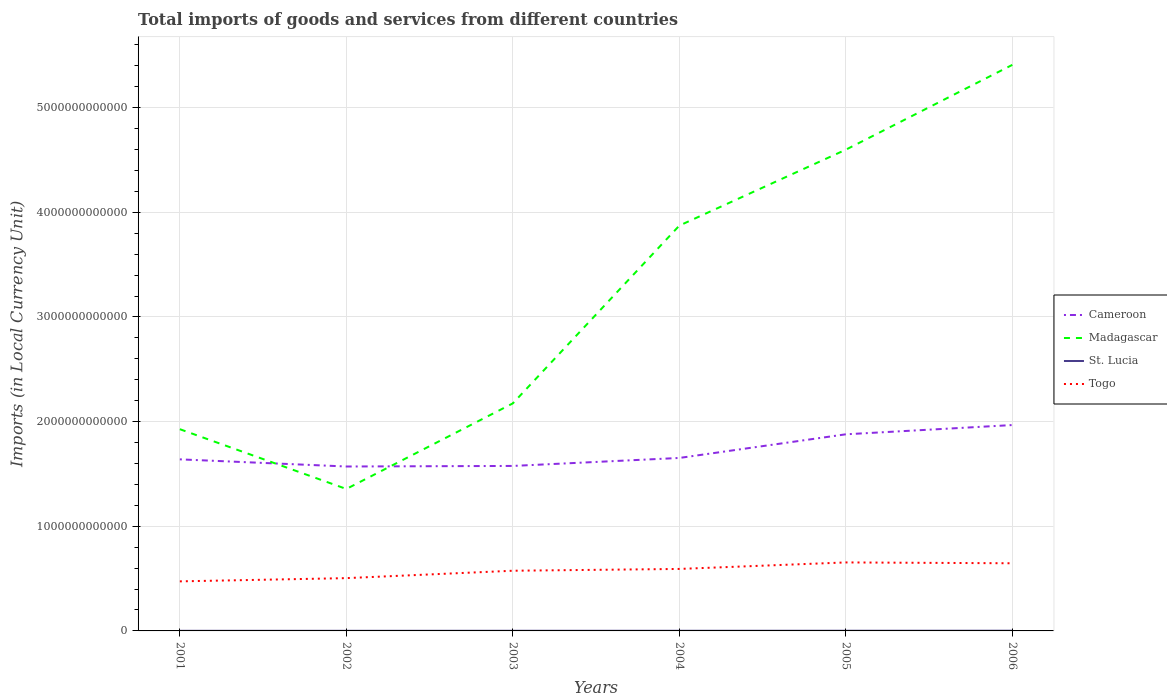Is the number of lines equal to the number of legend labels?
Provide a short and direct response. Yes. Across all years, what is the maximum Amount of goods and services imports in Madagascar?
Ensure brevity in your answer.  1.36e+12. In which year was the Amount of goods and services imports in Cameroon maximum?
Offer a very short reply. 2002. What is the total Amount of goods and services imports in St. Lucia in the graph?
Offer a terse response. -2.63e+08. What is the difference between the highest and the second highest Amount of goods and services imports in Cameroon?
Give a very brief answer. 3.96e+11. What is the difference between two consecutive major ticks on the Y-axis?
Offer a terse response. 1.00e+12. Are the values on the major ticks of Y-axis written in scientific E-notation?
Keep it short and to the point. No. Does the graph contain any zero values?
Offer a very short reply. No. Does the graph contain grids?
Ensure brevity in your answer.  Yes. How many legend labels are there?
Your answer should be very brief. 4. How are the legend labels stacked?
Offer a terse response. Vertical. What is the title of the graph?
Give a very brief answer. Total imports of goods and services from different countries. Does "Channel Islands" appear as one of the legend labels in the graph?
Offer a terse response. No. What is the label or title of the Y-axis?
Keep it short and to the point. Imports (in Local Currency Unit). What is the Imports (in Local Currency Unit) of Cameroon in 2001?
Make the answer very short. 1.64e+12. What is the Imports (in Local Currency Unit) of Madagascar in 2001?
Offer a very short reply. 1.93e+12. What is the Imports (in Local Currency Unit) in St. Lucia in 2001?
Offer a terse response. 1.09e+09. What is the Imports (in Local Currency Unit) in Togo in 2001?
Give a very brief answer. 4.74e+11. What is the Imports (in Local Currency Unit) in Cameroon in 2002?
Your answer should be compact. 1.57e+12. What is the Imports (in Local Currency Unit) of Madagascar in 2002?
Keep it short and to the point. 1.36e+12. What is the Imports (in Local Currency Unit) of St. Lucia in 2002?
Provide a succinct answer. 1.08e+09. What is the Imports (in Local Currency Unit) in Togo in 2002?
Your answer should be compact. 5.04e+11. What is the Imports (in Local Currency Unit) in Cameroon in 2003?
Your response must be concise. 1.58e+12. What is the Imports (in Local Currency Unit) of Madagascar in 2003?
Your response must be concise. 2.17e+12. What is the Imports (in Local Currency Unit) in St. Lucia in 2003?
Your answer should be very brief. 1.35e+09. What is the Imports (in Local Currency Unit) in Togo in 2003?
Offer a very short reply. 5.75e+11. What is the Imports (in Local Currency Unit) in Cameroon in 2004?
Provide a short and direct response. 1.65e+12. What is the Imports (in Local Currency Unit) in Madagascar in 2004?
Your answer should be very brief. 3.87e+12. What is the Imports (in Local Currency Unit) of St. Lucia in 2004?
Keep it short and to the point. 1.35e+09. What is the Imports (in Local Currency Unit) of Togo in 2004?
Provide a succinct answer. 5.92e+11. What is the Imports (in Local Currency Unit) of Cameroon in 2005?
Offer a terse response. 1.88e+12. What is the Imports (in Local Currency Unit) in Madagascar in 2005?
Make the answer very short. 4.60e+12. What is the Imports (in Local Currency Unit) in St. Lucia in 2005?
Ensure brevity in your answer.  1.61e+09. What is the Imports (in Local Currency Unit) in Togo in 2005?
Offer a very short reply. 6.54e+11. What is the Imports (in Local Currency Unit) of Cameroon in 2006?
Offer a very short reply. 1.97e+12. What is the Imports (in Local Currency Unit) in Madagascar in 2006?
Your response must be concise. 5.41e+12. What is the Imports (in Local Currency Unit) in St. Lucia in 2006?
Your answer should be compact. 1.91e+09. What is the Imports (in Local Currency Unit) in Togo in 2006?
Your answer should be very brief. 6.46e+11. Across all years, what is the maximum Imports (in Local Currency Unit) in Cameroon?
Give a very brief answer. 1.97e+12. Across all years, what is the maximum Imports (in Local Currency Unit) of Madagascar?
Your response must be concise. 5.41e+12. Across all years, what is the maximum Imports (in Local Currency Unit) in St. Lucia?
Give a very brief answer. 1.91e+09. Across all years, what is the maximum Imports (in Local Currency Unit) in Togo?
Offer a very short reply. 6.54e+11. Across all years, what is the minimum Imports (in Local Currency Unit) in Cameroon?
Your answer should be compact. 1.57e+12. Across all years, what is the minimum Imports (in Local Currency Unit) of Madagascar?
Your response must be concise. 1.36e+12. Across all years, what is the minimum Imports (in Local Currency Unit) of St. Lucia?
Ensure brevity in your answer.  1.08e+09. Across all years, what is the minimum Imports (in Local Currency Unit) in Togo?
Your answer should be very brief. 4.74e+11. What is the total Imports (in Local Currency Unit) of Cameroon in the graph?
Make the answer very short. 1.03e+13. What is the total Imports (in Local Currency Unit) in Madagascar in the graph?
Your answer should be compact. 1.93e+13. What is the total Imports (in Local Currency Unit) of St. Lucia in the graph?
Your answer should be very brief. 8.38e+09. What is the total Imports (in Local Currency Unit) of Togo in the graph?
Your response must be concise. 3.45e+12. What is the difference between the Imports (in Local Currency Unit) in Cameroon in 2001 and that in 2002?
Your answer should be compact. 6.83e+1. What is the difference between the Imports (in Local Currency Unit) in Madagascar in 2001 and that in 2002?
Provide a short and direct response. 5.71e+11. What is the difference between the Imports (in Local Currency Unit) in St. Lucia in 2001 and that in 2002?
Your answer should be very brief. 4.70e+06. What is the difference between the Imports (in Local Currency Unit) in Togo in 2001 and that in 2002?
Offer a terse response. -3.09e+1. What is the difference between the Imports (in Local Currency Unit) in Cameroon in 2001 and that in 2003?
Ensure brevity in your answer.  6.29e+1. What is the difference between the Imports (in Local Currency Unit) of Madagascar in 2001 and that in 2003?
Make the answer very short. -2.47e+11. What is the difference between the Imports (in Local Currency Unit) of St. Lucia in 2001 and that in 2003?
Offer a very short reply. -2.62e+08. What is the difference between the Imports (in Local Currency Unit) of Togo in 2001 and that in 2003?
Your response must be concise. -1.02e+11. What is the difference between the Imports (in Local Currency Unit) of Cameroon in 2001 and that in 2004?
Provide a short and direct response. -1.34e+1. What is the difference between the Imports (in Local Currency Unit) in Madagascar in 2001 and that in 2004?
Make the answer very short. -1.95e+12. What is the difference between the Imports (in Local Currency Unit) of St. Lucia in 2001 and that in 2004?
Make the answer very short. -2.63e+08. What is the difference between the Imports (in Local Currency Unit) in Togo in 2001 and that in 2004?
Offer a terse response. -1.19e+11. What is the difference between the Imports (in Local Currency Unit) of Cameroon in 2001 and that in 2005?
Provide a short and direct response. -2.39e+11. What is the difference between the Imports (in Local Currency Unit) in Madagascar in 2001 and that in 2005?
Provide a succinct answer. -2.67e+12. What is the difference between the Imports (in Local Currency Unit) of St. Lucia in 2001 and that in 2005?
Offer a terse response. -5.19e+08. What is the difference between the Imports (in Local Currency Unit) in Togo in 2001 and that in 2005?
Keep it short and to the point. -1.81e+11. What is the difference between the Imports (in Local Currency Unit) of Cameroon in 2001 and that in 2006?
Offer a terse response. -3.28e+11. What is the difference between the Imports (in Local Currency Unit) in Madagascar in 2001 and that in 2006?
Give a very brief answer. -3.48e+12. What is the difference between the Imports (in Local Currency Unit) in St. Lucia in 2001 and that in 2006?
Provide a short and direct response. -8.21e+08. What is the difference between the Imports (in Local Currency Unit) in Togo in 2001 and that in 2006?
Make the answer very short. -1.73e+11. What is the difference between the Imports (in Local Currency Unit) in Cameroon in 2002 and that in 2003?
Your response must be concise. -5.41e+09. What is the difference between the Imports (in Local Currency Unit) of Madagascar in 2002 and that in 2003?
Your answer should be very brief. -8.18e+11. What is the difference between the Imports (in Local Currency Unit) in St. Lucia in 2002 and that in 2003?
Keep it short and to the point. -2.67e+08. What is the difference between the Imports (in Local Currency Unit) in Togo in 2002 and that in 2003?
Make the answer very short. -7.07e+1. What is the difference between the Imports (in Local Currency Unit) in Cameroon in 2002 and that in 2004?
Provide a short and direct response. -8.17e+1. What is the difference between the Imports (in Local Currency Unit) of Madagascar in 2002 and that in 2004?
Your answer should be compact. -2.52e+12. What is the difference between the Imports (in Local Currency Unit) in St. Lucia in 2002 and that in 2004?
Offer a terse response. -2.68e+08. What is the difference between the Imports (in Local Currency Unit) of Togo in 2002 and that in 2004?
Give a very brief answer. -8.78e+1. What is the difference between the Imports (in Local Currency Unit) of Cameroon in 2002 and that in 2005?
Give a very brief answer. -3.08e+11. What is the difference between the Imports (in Local Currency Unit) in Madagascar in 2002 and that in 2005?
Make the answer very short. -3.24e+12. What is the difference between the Imports (in Local Currency Unit) in St. Lucia in 2002 and that in 2005?
Your response must be concise. -5.23e+08. What is the difference between the Imports (in Local Currency Unit) in Togo in 2002 and that in 2005?
Offer a terse response. -1.50e+11. What is the difference between the Imports (in Local Currency Unit) of Cameroon in 2002 and that in 2006?
Ensure brevity in your answer.  -3.96e+11. What is the difference between the Imports (in Local Currency Unit) in Madagascar in 2002 and that in 2006?
Provide a succinct answer. -4.05e+12. What is the difference between the Imports (in Local Currency Unit) of St. Lucia in 2002 and that in 2006?
Provide a short and direct response. -8.25e+08. What is the difference between the Imports (in Local Currency Unit) in Togo in 2002 and that in 2006?
Your answer should be very brief. -1.42e+11. What is the difference between the Imports (in Local Currency Unit) of Cameroon in 2003 and that in 2004?
Keep it short and to the point. -7.63e+1. What is the difference between the Imports (in Local Currency Unit) of Madagascar in 2003 and that in 2004?
Your answer should be very brief. -1.70e+12. What is the difference between the Imports (in Local Currency Unit) of St. Lucia in 2003 and that in 2004?
Provide a short and direct response. -1.60e+06. What is the difference between the Imports (in Local Currency Unit) in Togo in 2003 and that in 2004?
Keep it short and to the point. -1.71e+1. What is the difference between the Imports (in Local Currency Unit) of Cameroon in 2003 and that in 2005?
Ensure brevity in your answer.  -3.02e+11. What is the difference between the Imports (in Local Currency Unit) of Madagascar in 2003 and that in 2005?
Give a very brief answer. -2.42e+12. What is the difference between the Imports (in Local Currency Unit) of St. Lucia in 2003 and that in 2005?
Your answer should be very brief. -2.57e+08. What is the difference between the Imports (in Local Currency Unit) in Togo in 2003 and that in 2005?
Your answer should be very brief. -7.93e+1. What is the difference between the Imports (in Local Currency Unit) of Cameroon in 2003 and that in 2006?
Offer a terse response. -3.91e+11. What is the difference between the Imports (in Local Currency Unit) in Madagascar in 2003 and that in 2006?
Your answer should be compact. -3.23e+12. What is the difference between the Imports (in Local Currency Unit) in St. Lucia in 2003 and that in 2006?
Provide a succinct answer. -5.59e+08. What is the difference between the Imports (in Local Currency Unit) of Togo in 2003 and that in 2006?
Your answer should be very brief. -7.13e+1. What is the difference between the Imports (in Local Currency Unit) in Cameroon in 2004 and that in 2005?
Provide a succinct answer. -2.26e+11. What is the difference between the Imports (in Local Currency Unit) in Madagascar in 2004 and that in 2005?
Offer a terse response. -7.25e+11. What is the difference between the Imports (in Local Currency Unit) in St. Lucia in 2004 and that in 2005?
Your answer should be compact. -2.55e+08. What is the difference between the Imports (in Local Currency Unit) in Togo in 2004 and that in 2005?
Make the answer very short. -6.22e+1. What is the difference between the Imports (in Local Currency Unit) in Cameroon in 2004 and that in 2006?
Make the answer very short. -3.14e+11. What is the difference between the Imports (in Local Currency Unit) of Madagascar in 2004 and that in 2006?
Your answer should be very brief. -1.54e+12. What is the difference between the Imports (in Local Currency Unit) in St. Lucia in 2004 and that in 2006?
Ensure brevity in your answer.  -5.57e+08. What is the difference between the Imports (in Local Currency Unit) in Togo in 2004 and that in 2006?
Ensure brevity in your answer.  -5.42e+1. What is the difference between the Imports (in Local Currency Unit) in Cameroon in 2005 and that in 2006?
Your response must be concise. -8.83e+1. What is the difference between the Imports (in Local Currency Unit) in Madagascar in 2005 and that in 2006?
Ensure brevity in your answer.  -8.10e+11. What is the difference between the Imports (in Local Currency Unit) of St. Lucia in 2005 and that in 2006?
Provide a short and direct response. -3.02e+08. What is the difference between the Imports (in Local Currency Unit) of Togo in 2005 and that in 2006?
Offer a very short reply. 8.03e+09. What is the difference between the Imports (in Local Currency Unit) of Cameroon in 2001 and the Imports (in Local Currency Unit) of Madagascar in 2002?
Ensure brevity in your answer.  2.83e+11. What is the difference between the Imports (in Local Currency Unit) in Cameroon in 2001 and the Imports (in Local Currency Unit) in St. Lucia in 2002?
Keep it short and to the point. 1.64e+12. What is the difference between the Imports (in Local Currency Unit) of Cameroon in 2001 and the Imports (in Local Currency Unit) of Togo in 2002?
Offer a very short reply. 1.13e+12. What is the difference between the Imports (in Local Currency Unit) of Madagascar in 2001 and the Imports (in Local Currency Unit) of St. Lucia in 2002?
Offer a terse response. 1.93e+12. What is the difference between the Imports (in Local Currency Unit) of Madagascar in 2001 and the Imports (in Local Currency Unit) of Togo in 2002?
Offer a very short reply. 1.42e+12. What is the difference between the Imports (in Local Currency Unit) of St. Lucia in 2001 and the Imports (in Local Currency Unit) of Togo in 2002?
Offer a very short reply. -5.03e+11. What is the difference between the Imports (in Local Currency Unit) of Cameroon in 2001 and the Imports (in Local Currency Unit) of Madagascar in 2003?
Ensure brevity in your answer.  -5.35e+11. What is the difference between the Imports (in Local Currency Unit) in Cameroon in 2001 and the Imports (in Local Currency Unit) in St. Lucia in 2003?
Offer a terse response. 1.64e+12. What is the difference between the Imports (in Local Currency Unit) of Cameroon in 2001 and the Imports (in Local Currency Unit) of Togo in 2003?
Give a very brief answer. 1.06e+12. What is the difference between the Imports (in Local Currency Unit) in Madagascar in 2001 and the Imports (in Local Currency Unit) in St. Lucia in 2003?
Your answer should be compact. 1.93e+12. What is the difference between the Imports (in Local Currency Unit) in Madagascar in 2001 and the Imports (in Local Currency Unit) in Togo in 2003?
Offer a terse response. 1.35e+12. What is the difference between the Imports (in Local Currency Unit) in St. Lucia in 2001 and the Imports (in Local Currency Unit) in Togo in 2003?
Offer a terse response. -5.74e+11. What is the difference between the Imports (in Local Currency Unit) of Cameroon in 2001 and the Imports (in Local Currency Unit) of Madagascar in 2004?
Provide a short and direct response. -2.23e+12. What is the difference between the Imports (in Local Currency Unit) in Cameroon in 2001 and the Imports (in Local Currency Unit) in St. Lucia in 2004?
Offer a terse response. 1.64e+12. What is the difference between the Imports (in Local Currency Unit) of Cameroon in 2001 and the Imports (in Local Currency Unit) of Togo in 2004?
Your response must be concise. 1.05e+12. What is the difference between the Imports (in Local Currency Unit) in Madagascar in 2001 and the Imports (in Local Currency Unit) in St. Lucia in 2004?
Offer a terse response. 1.93e+12. What is the difference between the Imports (in Local Currency Unit) in Madagascar in 2001 and the Imports (in Local Currency Unit) in Togo in 2004?
Provide a short and direct response. 1.34e+12. What is the difference between the Imports (in Local Currency Unit) of St. Lucia in 2001 and the Imports (in Local Currency Unit) of Togo in 2004?
Your answer should be very brief. -5.91e+11. What is the difference between the Imports (in Local Currency Unit) in Cameroon in 2001 and the Imports (in Local Currency Unit) in Madagascar in 2005?
Your response must be concise. -2.96e+12. What is the difference between the Imports (in Local Currency Unit) of Cameroon in 2001 and the Imports (in Local Currency Unit) of St. Lucia in 2005?
Offer a terse response. 1.64e+12. What is the difference between the Imports (in Local Currency Unit) of Cameroon in 2001 and the Imports (in Local Currency Unit) of Togo in 2005?
Your answer should be compact. 9.85e+11. What is the difference between the Imports (in Local Currency Unit) in Madagascar in 2001 and the Imports (in Local Currency Unit) in St. Lucia in 2005?
Provide a succinct answer. 1.93e+12. What is the difference between the Imports (in Local Currency Unit) in Madagascar in 2001 and the Imports (in Local Currency Unit) in Togo in 2005?
Ensure brevity in your answer.  1.27e+12. What is the difference between the Imports (in Local Currency Unit) in St. Lucia in 2001 and the Imports (in Local Currency Unit) in Togo in 2005?
Your response must be concise. -6.53e+11. What is the difference between the Imports (in Local Currency Unit) in Cameroon in 2001 and the Imports (in Local Currency Unit) in Madagascar in 2006?
Your answer should be compact. -3.77e+12. What is the difference between the Imports (in Local Currency Unit) of Cameroon in 2001 and the Imports (in Local Currency Unit) of St. Lucia in 2006?
Ensure brevity in your answer.  1.64e+12. What is the difference between the Imports (in Local Currency Unit) in Cameroon in 2001 and the Imports (in Local Currency Unit) in Togo in 2006?
Offer a terse response. 9.93e+11. What is the difference between the Imports (in Local Currency Unit) in Madagascar in 2001 and the Imports (in Local Currency Unit) in St. Lucia in 2006?
Your answer should be compact. 1.93e+12. What is the difference between the Imports (in Local Currency Unit) in Madagascar in 2001 and the Imports (in Local Currency Unit) in Togo in 2006?
Offer a very short reply. 1.28e+12. What is the difference between the Imports (in Local Currency Unit) of St. Lucia in 2001 and the Imports (in Local Currency Unit) of Togo in 2006?
Keep it short and to the point. -6.45e+11. What is the difference between the Imports (in Local Currency Unit) of Cameroon in 2002 and the Imports (in Local Currency Unit) of Madagascar in 2003?
Ensure brevity in your answer.  -6.03e+11. What is the difference between the Imports (in Local Currency Unit) of Cameroon in 2002 and the Imports (in Local Currency Unit) of St. Lucia in 2003?
Give a very brief answer. 1.57e+12. What is the difference between the Imports (in Local Currency Unit) of Cameroon in 2002 and the Imports (in Local Currency Unit) of Togo in 2003?
Offer a very short reply. 9.96e+11. What is the difference between the Imports (in Local Currency Unit) in Madagascar in 2002 and the Imports (in Local Currency Unit) in St. Lucia in 2003?
Ensure brevity in your answer.  1.35e+12. What is the difference between the Imports (in Local Currency Unit) in Madagascar in 2002 and the Imports (in Local Currency Unit) in Togo in 2003?
Keep it short and to the point. 7.81e+11. What is the difference between the Imports (in Local Currency Unit) of St. Lucia in 2002 and the Imports (in Local Currency Unit) of Togo in 2003?
Offer a terse response. -5.74e+11. What is the difference between the Imports (in Local Currency Unit) of Cameroon in 2002 and the Imports (in Local Currency Unit) of Madagascar in 2004?
Make the answer very short. -2.30e+12. What is the difference between the Imports (in Local Currency Unit) of Cameroon in 2002 and the Imports (in Local Currency Unit) of St. Lucia in 2004?
Offer a very short reply. 1.57e+12. What is the difference between the Imports (in Local Currency Unit) in Cameroon in 2002 and the Imports (in Local Currency Unit) in Togo in 2004?
Provide a short and direct response. 9.79e+11. What is the difference between the Imports (in Local Currency Unit) of Madagascar in 2002 and the Imports (in Local Currency Unit) of St. Lucia in 2004?
Offer a very short reply. 1.35e+12. What is the difference between the Imports (in Local Currency Unit) of Madagascar in 2002 and the Imports (in Local Currency Unit) of Togo in 2004?
Provide a succinct answer. 7.64e+11. What is the difference between the Imports (in Local Currency Unit) in St. Lucia in 2002 and the Imports (in Local Currency Unit) in Togo in 2004?
Make the answer very short. -5.91e+11. What is the difference between the Imports (in Local Currency Unit) of Cameroon in 2002 and the Imports (in Local Currency Unit) of Madagascar in 2005?
Ensure brevity in your answer.  -3.03e+12. What is the difference between the Imports (in Local Currency Unit) of Cameroon in 2002 and the Imports (in Local Currency Unit) of St. Lucia in 2005?
Give a very brief answer. 1.57e+12. What is the difference between the Imports (in Local Currency Unit) in Cameroon in 2002 and the Imports (in Local Currency Unit) in Togo in 2005?
Make the answer very short. 9.17e+11. What is the difference between the Imports (in Local Currency Unit) of Madagascar in 2002 and the Imports (in Local Currency Unit) of St. Lucia in 2005?
Offer a very short reply. 1.35e+12. What is the difference between the Imports (in Local Currency Unit) in Madagascar in 2002 and the Imports (in Local Currency Unit) in Togo in 2005?
Ensure brevity in your answer.  7.02e+11. What is the difference between the Imports (in Local Currency Unit) in St. Lucia in 2002 and the Imports (in Local Currency Unit) in Togo in 2005?
Provide a short and direct response. -6.53e+11. What is the difference between the Imports (in Local Currency Unit) in Cameroon in 2002 and the Imports (in Local Currency Unit) in Madagascar in 2006?
Your response must be concise. -3.84e+12. What is the difference between the Imports (in Local Currency Unit) in Cameroon in 2002 and the Imports (in Local Currency Unit) in St. Lucia in 2006?
Offer a very short reply. 1.57e+12. What is the difference between the Imports (in Local Currency Unit) in Cameroon in 2002 and the Imports (in Local Currency Unit) in Togo in 2006?
Make the answer very short. 9.25e+11. What is the difference between the Imports (in Local Currency Unit) in Madagascar in 2002 and the Imports (in Local Currency Unit) in St. Lucia in 2006?
Your response must be concise. 1.35e+12. What is the difference between the Imports (in Local Currency Unit) in Madagascar in 2002 and the Imports (in Local Currency Unit) in Togo in 2006?
Offer a very short reply. 7.10e+11. What is the difference between the Imports (in Local Currency Unit) of St. Lucia in 2002 and the Imports (in Local Currency Unit) of Togo in 2006?
Make the answer very short. -6.45e+11. What is the difference between the Imports (in Local Currency Unit) of Cameroon in 2003 and the Imports (in Local Currency Unit) of Madagascar in 2004?
Your answer should be very brief. -2.30e+12. What is the difference between the Imports (in Local Currency Unit) in Cameroon in 2003 and the Imports (in Local Currency Unit) in St. Lucia in 2004?
Your answer should be very brief. 1.58e+12. What is the difference between the Imports (in Local Currency Unit) in Cameroon in 2003 and the Imports (in Local Currency Unit) in Togo in 2004?
Provide a succinct answer. 9.84e+11. What is the difference between the Imports (in Local Currency Unit) in Madagascar in 2003 and the Imports (in Local Currency Unit) in St. Lucia in 2004?
Keep it short and to the point. 2.17e+12. What is the difference between the Imports (in Local Currency Unit) of Madagascar in 2003 and the Imports (in Local Currency Unit) of Togo in 2004?
Give a very brief answer. 1.58e+12. What is the difference between the Imports (in Local Currency Unit) of St. Lucia in 2003 and the Imports (in Local Currency Unit) of Togo in 2004?
Ensure brevity in your answer.  -5.91e+11. What is the difference between the Imports (in Local Currency Unit) of Cameroon in 2003 and the Imports (in Local Currency Unit) of Madagascar in 2005?
Your response must be concise. -3.02e+12. What is the difference between the Imports (in Local Currency Unit) of Cameroon in 2003 and the Imports (in Local Currency Unit) of St. Lucia in 2005?
Offer a terse response. 1.57e+12. What is the difference between the Imports (in Local Currency Unit) of Cameroon in 2003 and the Imports (in Local Currency Unit) of Togo in 2005?
Your answer should be very brief. 9.22e+11. What is the difference between the Imports (in Local Currency Unit) in Madagascar in 2003 and the Imports (in Local Currency Unit) in St. Lucia in 2005?
Ensure brevity in your answer.  2.17e+12. What is the difference between the Imports (in Local Currency Unit) in Madagascar in 2003 and the Imports (in Local Currency Unit) in Togo in 2005?
Offer a terse response. 1.52e+12. What is the difference between the Imports (in Local Currency Unit) in St. Lucia in 2003 and the Imports (in Local Currency Unit) in Togo in 2005?
Make the answer very short. -6.53e+11. What is the difference between the Imports (in Local Currency Unit) in Cameroon in 2003 and the Imports (in Local Currency Unit) in Madagascar in 2006?
Provide a succinct answer. -3.83e+12. What is the difference between the Imports (in Local Currency Unit) in Cameroon in 2003 and the Imports (in Local Currency Unit) in St. Lucia in 2006?
Give a very brief answer. 1.57e+12. What is the difference between the Imports (in Local Currency Unit) in Cameroon in 2003 and the Imports (in Local Currency Unit) in Togo in 2006?
Offer a terse response. 9.30e+11. What is the difference between the Imports (in Local Currency Unit) in Madagascar in 2003 and the Imports (in Local Currency Unit) in St. Lucia in 2006?
Ensure brevity in your answer.  2.17e+12. What is the difference between the Imports (in Local Currency Unit) of Madagascar in 2003 and the Imports (in Local Currency Unit) of Togo in 2006?
Ensure brevity in your answer.  1.53e+12. What is the difference between the Imports (in Local Currency Unit) in St. Lucia in 2003 and the Imports (in Local Currency Unit) in Togo in 2006?
Offer a terse response. -6.45e+11. What is the difference between the Imports (in Local Currency Unit) of Cameroon in 2004 and the Imports (in Local Currency Unit) of Madagascar in 2005?
Your answer should be very brief. -2.95e+12. What is the difference between the Imports (in Local Currency Unit) of Cameroon in 2004 and the Imports (in Local Currency Unit) of St. Lucia in 2005?
Your answer should be compact. 1.65e+12. What is the difference between the Imports (in Local Currency Unit) of Cameroon in 2004 and the Imports (in Local Currency Unit) of Togo in 2005?
Offer a very short reply. 9.98e+11. What is the difference between the Imports (in Local Currency Unit) in Madagascar in 2004 and the Imports (in Local Currency Unit) in St. Lucia in 2005?
Make the answer very short. 3.87e+12. What is the difference between the Imports (in Local Currency Unit) of Madagascar in 2004 and the Imports (in Local Currency Unit) of Togo in 2005?
Your answer should be compact. 3.22e+12. What is the difference between the Imports (in Local Currency Unit) of St. Lucia in 2004 and the Imports (in Local Currency Unit) of Togo in 2005?
Ensure brevity in your answer.  -6.53e+11. What is the difference between the Imports (in Local Currency Unit) of Cameroon in 2004 and the Imports (in Local Currency Unit) of Madagascar in 2006?
Your response must be concise. -3.76e+12. What is the difference between the Imports (in Local Currency Unit) of Cameroon in 2004 and the Imports (in Local Currency Unit) of St. Lucia in 2006?
Offer a very short reply. 1.65e+12. What is the difference between the Imports (in Local Currency Unit) of Cameroon in 2004 and the Imports (in Local Currency Unit) of Togo in 2006?
Give a very brief answer. 1.01e+12. What is the difference between the Imports (in Local Currency Unit) of Madagascar in 2004 and the Imports (in Local Currency Unit) of St. Lucia in 2006?
Make the answer very short. 3.87e+12. What is the difference between the Imports (in Local Currency Unit) in Madagascar in 2004 and the Imports (in Local Currency Unit) in Togo in 2006?
Your answer should be very brief. 3.23e+12. What is the difference between the Imports (in Local Currency Unit) of St. Lucia in 2004 and the Imports (in Local Currency Unit) of Togo in 2006?
Your answer should be compact. -6.45e+11. What is the difference between the Imports (in Local Currency Unit) of Cameroon in 2005 and the Imports (in Local Currency Unit) of Madagascar in 2006?
Provide a succinct answer. -3.53e+12. What is the difference between the Imports (in Local Currency Unit) of Cameroon in 2005 and the Imports (in Local Currency Unit) of St. Lucia in 2006?
Offer a terse response. 1.88e+12. What is the difference between the Imports (in Local Currency Unit) of Cameroon in 2005 and the Imports (in Local Currency Unit) of Togo in 2006?
Ensure brevity in your answer.  1.23e+12. What is the difference between the Imports (in Local Currency Unit) in Madagascar in 2005 and the Imports (in Local Currency Unit) in St. Lucia in 2006?
Give a very brief answer. 4.60e+12. What is the difference between the Imports (in Local Currency Unit) of Madagascar in 2005 and the Imports (in Local Currency Unit) of Togo in 2006?
Offer a very short reply. 3.95e+12. What is the difference between the Imports (in Local Currency Unit) of St. Lucia in 2005 and the Imports (in Local Currency Unit) of Togo in 2006?
Offer a terse response. -6.45e+11. What is the average Imports (in Local Currency Unit) in Cameroon per year?
Your answer should be compact. 1.71e+12. What is the average Imports (in Local Currency Unit) in Madagascar per year?
Offer a terse response. 3.22e+12. What is the average Imports (in Local Currency Unit) in St. Lucia per year?
Keep it short and to the point. 1.40e+09. What is the average Imports (in Local Currency Unit) of Togo per year?
Offer a terse response. 5.74e+11. In the year 2001, what is the difference between the Imports (in Local Currency Unit) of Cameroon and Imports (in Local Currency Unit) of Madagascar?
Offer a very short reply. -2.88e+11. In the year 2001, what is the difference between the Imports (in Local Currency Unit) in Cameroon and Imports (in Local Currency Unit) in St. Lucia?
Provide a short and direct response. 1.64e+12. In the year 2001, what is the difference between the Imports (in Local Currency Unit) in Cameroon and Imports (in Local Currency Unit) in Togo?
Offer a very short reply. 1.17e+12. In the year 2001, what is the difference between the Imports (in Local Currency Unit) of Madagascar and Imports (in Local Currency Unit) of St. Lucia?
Provide a short and direct response. 1.93e+12. In the year 2001, what is the difference between the Imports (in Local Currency Unit) in Madagascar and Imports (in Local Currency Unit) in Togo?
Make the answer very short. 1.45e+12. In the year 2001, what is the difference between the Imports (in Local Currency Unit) in St. Lucia and Imports (in Local Currency Unit) in Togo?
Give a very brief answer. -4.72e+11. In the year 2002, what is the difference between the Imports (in Local Currency Unit) in Cameroon and Imports (in Local Currency Unit) in Madagascar?
Ensure brevity in your answer.  2.15e+11. In the year 2002, what is the difference between the Imports (in Local Currency Unit) in Cameroon and Imports (in Local Currency Unit) in St. Lucia?
Ensure brevity in your answer.  1.57e+12. In the year 2002, what is the difference between the Imports (in Local Currency Unit) in Cameroon and Imports (in Local Currency Unit) in Togo?
Your answer should be compact. 1.07e+12. In the year 2002, what is the difference between the Imports (in Local Currency Unit) of Madagascar and Imports (in Local Currency Unit) of St. Lucia?
Ensure brevity in your answer.  1.36e+12. In the year 2002, what is the difference between the Imports (in Local Currency Unit) of Madagascar and Imports (in Local Currency Unit) of Togo?
Give a very brief answer. 8.52e+11. In the year 2002, what is the difference between the Imports (in Local Currency Unit) of St. Lucia and Imports (in Local Currency Unit) of Togo?
Ensure brevity in your answer.  -5.03e+11. In the year 2003, what is the difference between the Imports (in Local Currency Unit) of Cameroon and Imports (in Local Currency Unit) of Madagascar?
Provide a succinct answer. -5.98e+11. In the year 2003, what is the difference between the Imports (in Local Currency Unit) in Cameroon and Imports (in Local Currency Unit) in St. Lucia?
Your response must be concise. 1.58e+12. In the year 2003, what is the difference between the Imports (in Local Currency Unit) of Cameroon and Imports (in Local Currency Unit) of Togo?
Give a very brief answer. 1.00e+12. In the year 2003, what is the difference between the Imports (in Local Currency Unit) in Madagascar and Imports (in Local Currency Unit) in St. Lucia?
Provide a succinct answer. 2.17e+12. In the year 2003, what is the difference between the Imports (in Local Currency Unit) of Madagascar and Imports (in Local Currency Unit) of Togo?
Provide a succinct answer. 1.60e+12. In the year 2003, what is the difference between the Imports (in Local Currency Unit) of St. Lucia and Imports (in Local Currency Unit) of Togo?
Your response must be concise. -5.74e+11. In the year 2004, what is the difference between the Imports (in Local Currency Unit) in Cameroon and Imports (in Local Currency Unit) in Madagascar?
Your response must be concise. -2.22e+12. In the year 2004, what is the difference between the Imports (in Local Currency Unit) of Cameroon and Imports (in Local Currency Unit) of St. Lucia?
Your answer should be compact. 1.65e+12. In the year 2004, what is the difference between the Imports (in Local Currency Unit) of Cameroon and Imports (in Local Currency Unit) of Togo?
Give a very brief answer. 1.06e+12. In the year 2004, what is the difference between the Imports (in Local Currency Unit) of Madagascar and Imports (in Local Currency Unit) of St. Lucia?
Provide a succinct answer. 3.87e+12. In the year 2004, what is the difference between the Imports (in Local Currency Unit) of Madagascar and Imports (in Local Currency Unit) of Togo?
Your answer should be compact. 3.28e+12. In the year 2004, what is the difference between the Imports (in Local Currency Unit) of St. Lucia and Imports (in Local Currency Unit) of Togo?
Ensure brevity in your answer.  -5.91e+11. In the year 2005, what is the difference between the Imports (in Local Currency Unit) in Cameroon and Imports (in Local Currency Unit) in Madagascar?
Ensure brevity in your answer.  -2.72e+12. In the year 2005, what is the difference between the Imports (in Local Currency Unit) in Cameroon and Imports (in Local Currency Unit) in St. Lucia?
Ensure brevity in your answer.  1.88e+12. In the year 2005, what is the difference between the Imports (in Local Currency Unit) of Cameroon and Imports (in Local Currency Unit) of Togo?
Offer a terse response. 1.22e+12. In the year 2005, what is the difference between the Imports (in Local Currency Unit) in Madagascar and Imports (in Local Currency Unit) in St. Lucia?
Your response must be concise. 4.60e+12. In the year 2005, what is the difference between the Imports (in Local Currency Unit) of Madagascar and Imports (in Local Currency Unit) of Togo?
Ensure brevity in your answer.  3.94e+12. In the year 2005, what is the difference between the Imports (in Local Currency Unit) in St. Lucia and Imports (in Local Currency Unit) in Togo?
Your answer should be very brief. -6.53e+11. In the year 2006, what is the difference between the Imports (in Local Currency Unit) in Cameroon and Imports (in Local Currency Unit) in Madagascar?
Provide a short and direct response. -3.44e+12. In the year 2006, what is the difference between the Imports (in Local Currency Unit) in Cameroon and Imports (in Local Currency Unit) in St. Lucia?
Provide a short and direct response. 1.97e+12. In the year 2006, what is the difference between the Imports (in Local Currency Unit) of Cameroon and Imports (in Local Currency Unit) of Togo?
Offer a terse response. 1.32e+12. In the year 2006, what is the difference between the Imports (in Local Currency Unit) in Madagascar and Imports (in Local Currency Unit) in St. Lucia?
Offer a very short reply. 5.41e+12. In the year 2006, what is the difference between the Imports (in Local Currency Unit) of Madagascar and Imports (in Local Currency Unit) of Togo?
Keep it short and to the point. 4.76e+12. In the year 2006, what is the difference between the Imports (in Local Currency Unit) in St. Lucia and Imports (in Local Currency Unit) in Togo?
Your answer should be compact. -6.44e+11. What is the ratio of the Imports (in Local Currency Unit) of Cameroon in 2001 to that in 2002?
Offer a terse response. 1.04. What is the ratio of the Imports (in Local Currency Unit) in Madagascar in 2001 to that in 2002?
Keep it short and to the point. 1.42. What is the ratio of the Imports (in Local Currency Unit) in St. Lucia in 2001 to that in 2002?
Ensure brevity in your answer.  1. What is the ratio of the Imports (in Local Currency Unit) of Togo in 2001 to that in 2002?
Offer a very short reply. 0.94. What is the ratio of the Imports (in Local Currency Unit) of Cameroon in 2001 to that in 2003?
Keep it short and to the point. 1.04. What is the ratio of the Imports (in Local Currency Unit) in Madagascar in 2001 to that in 2003?
Provide a succinct answer. 0.89. What is the ratio of the Imports (in Local Currency Unit) in St. Lucia in 2001 to that in 2003?
Your answer should be very brief. 0.81. What is the ratio of the Imports (in Local Currency Unit) in Togo in 2001 to that in 2003?
Give a very brief answer. 0.82. What is the ratio of the Imports (in Local Currency Unit) in Cameroon in 2001 to that in 2004?
Give a very brief answer. 0.99. What is the ratio of the Imports (in Local Currency Unit) in Madagascar in 2001 to that in 2004?
Keep it short and to the point. 0.5. What is the ratio of the Imports (in Local Currency Unit) in St. Lucia in 2001 to that in 2004?
Your answer should be compact. 0.8. What is the ratio of the Imports (in Local Currency Unit) in Togo in 2001 to that in 2004?
Make the answer very short. 0.8. What is the ratio of the Imports (in Local Currency Unit) of Cameroon in 2001 to that in 2005?
Your answer should be very brief. 0.87. What is the ratio of the Imports (in Local Currency Unit) in Madagascar in 2001 to that in 2005?
Make the answer very short. 0.42. What is the ratio of the Imports (in Local Currency Unit) of St. Lucia in 2001 to that in 2005?
Make the answer very short. 0.68. What is the ratio of the Imports (in Local Currency Unit) of Togo in 2001 to that in 2005?
Provide a succinct answer. 0.72. What is the ratio of the Imports (in Local Currency Unit) in Cameroon in 2001 to that in 2006?
Provide a succinct answer. 0.83. What is the ratio of the Imports (in Local Currency Unit) of Madagascar in 2001 to that in 2006?
Your response must be concise. 0.36. What is the ratio of the Imports (in Local Currency Unit) in St. Lucia in 2001 to that in 2006?
Ensure brevity in your answer.  0.57. What is the ratio of the Imports (in Local Currency Unit) in Togo in 2001 to that in 2006?
Ensure brevity in your answer.  0.73. What is the ratio of the Imports (in Local Currency Unit) in Madagascar in 2002 to that in 2003?
Provide a short and direct response. 0.62. What is the ratio of the Imports (in Local Currency Unit) of St. Lucia in 2002 to that in 2003?
Your answer should be compact. 0.8. What is the ratio of the Imports (in Local Currency Unit) in Togo in 2002 to that in 2003?
Offer a terse response. 0.88. What is the ratio of the Imports (in Local Currency Unit) in Cameroon in 2002 to that in 2004?
Keep it short and to the point. 0.95. What is the ratio of the Imports (in Local Currency Unit) in Madagascar in 2002 to that in 2004?
Offer a very short reply. 0.35. What is the ratio of the Imports (in Local Currency Unit) in St. Lucia in 2002 to that in 2004?
Offer a terse response. 0.8. What is the ratio of the Imports (in Local Currency Unit) of Togo in 2002 to that in 2004?
Keep it short and to the point. 0.85. What is the ratio of the Imports (in Local Currency Unit) in Cameroon in 2002 to that in 2005?
Your response must be concise. 0.84. What is the ratio of the Imports (in Local Currency Unit) in Madagascar in 2002 to that in 2005?
Your answer should be very brief. 0.29. What is the ratio of the Imports (in Local Currency Unit) in St. Lucia in 2002 to that in 2005?
Your response must be concise. 0.67. What is the ratio of the Imports (in Local Currency Unit) in Togo in 2002 to that in 2005?
Give a very brief answer. 0.77. What is the ratio of the Imports (in Local Currency Unit) in Cameroon in 2002 to that in 2006?
Your response must be concise. 0.8. What is the ratio of the Imports (in Local Currency Unit) of Madagascar in 2002 to that in 2006?
Give a very brief answer. 0.25. What is the ratio of the Imports (in Local Currency Unit) in St. Lucia in 2002 to that in 2006?
Keep it short and to the point. 0.57. What is the ratio of the Imports (in Local Currency Unit) of Togo in 2002 to that in 2006?
Give a very brief answer. 0.78. What is the ratio of the Imports (in Local Currency Unit) of Cameroon in 2003 to that in 2004?
Provide a short and direct response. 0.95. What is the ratio of the Imports (in Local Currency Unit) of Madagascar in 2003 to that in 2004?
Make the answer very short. 0.56. What is the ratio of the Imports (in Local Currency Unit) of St. Lucia in 2003 to that in 2004?
Ensure brevity in your answer.  1. What is the ratio of the Imports (in Local Currency Unit) in Togo in 2003 to that in 2004?
Provide a short and direct response. 0.97. What is the ratio of the Imports (in Local Currency Unit) of Cameroon in 2003 to that in 2005?
Offer a terse response. 0.84. What is the ratio of the Imports (in Local Currency Unit) in Madagascar in 2003 to that in 2005?
Offer a terse response. 0.47. What is the ratio of the Imports (in Local Currency Unit) of St. Lucia in 2003 to that in 2005?
Your response must be concise. 0.84. What is the ratio of the Imports (in Local Currency Unit) of Togo in 2003 to that in 2005?
Provide a succinct answer. 0.88. What is the ratio of the Imports (in Local Currency Unit) in Cameroon in 2003 to that in 2006?
Your answer should be very brief. 0.8. What is the ratio of the Imports (in Local Currency Unit) in Madagascar in 2003 to that in 2006?
Offer a very short reply. 0.4. What is the ratio of the Imports (in Local Currency Unit) in St. Lucia in 2003 to that in 2006?
Ensure brevity in your answer.  0.71. What is the ratio of the Imports (in Local Currency Unit) of Togo in 2003 to that in 2006?
Offer a terse response. 0.89. What is the ratio of the Imports (in Local Currency Unit) of Cameroon in 2004 to that in 2005?
Offer a very short reply. 0.88. What is the ratio of the Imports (in Local Currency Unit) of Madagascar in 2004 to that in 2005?
Provide a short and direct response. 0.84. What is the ratio of the Imports (in Local Currency Unit) in St. Lucia in 2004 to that in 2005?
Your answer should be compact. 0.84. What is the ratio of the Imports (in Local Currency Unit) of Togo in 2004 to that in 2005?
Your answer should be very brief. 0.9. What is the ratio of the Imports (in Local Currency Unit) of Cameroon in 2004 to that in 2006?
Give a very brief answer. 0.84. What is the ratio of the Imports (in Local Currency Unit) of Madagascar in 2004 to that in 2006?
Give a very brief answer. 0.72. What is the ratio of the Imports (in Local Currency Unit) of St. Lucia in 2004 to that in 2006?
Your answer should be compact. 0.71. What is the ratio of the Imports (in Local Currency Unit) in Togo in 2004 to that in 2006?
Provide a short and direct response. 0.92. What is the ratio of the Imports (in Local Currency Unit) in Cameroon in 2005 to that in 2006?
Make the answer very short. 0.96. What is the ratio of the Imports (in Local Currency Unit) in Madagascar in 2005 to that in 2006?
Offer a very short reply. 0.85. What is the ratio of the Imports (in Local Currency Unit) of St. Lucia in 2005 to that in 2006?
Offer a very short reply. 0.84. What is the ratio of the Imports (in Local Currency Unit) in Togo in 2005 to that in 2006?
Provide a succinct answer. 1.01. What is the difference between the highest and the second highest Imports (in Local Currency Unit) of Cameroon?
Provide a short and direct response. 8.83e+1. What is the difference between the highest and the second highest Imports (in Local Currency Unit) in Madagascar?
Offer a very short reply. 8.10e+11. What is the difference between the highest and the second highest Imports (in Local Currency Unit) in St. Lucia?
Make the answer very short. 3.02e+08. What is the difference between the highest and the second highest Imports (in Local Currency Unit) in Togo?
Your response must be concise. 8.03e+09. What is the difference between the highest and the lowest Imports (in Local Currency Unit) of Cameroon?
Ensure brevity in your answer.  3.96e+11. What is the difference between the highest and the lowest Imports (in Local Currency Unit) of Madagascar?
Offer a terse response. 4.05e+12. What is the difference between the highest and the lowest Imports (in Local Currency Unit) in St. Lucia?
Your answer should be compact. 8.25e+08. What is the difference between the highest and the lowest Imports (in Local Currency Unit) in Togo?
Your answer should be very brief. 1.81e+11. 